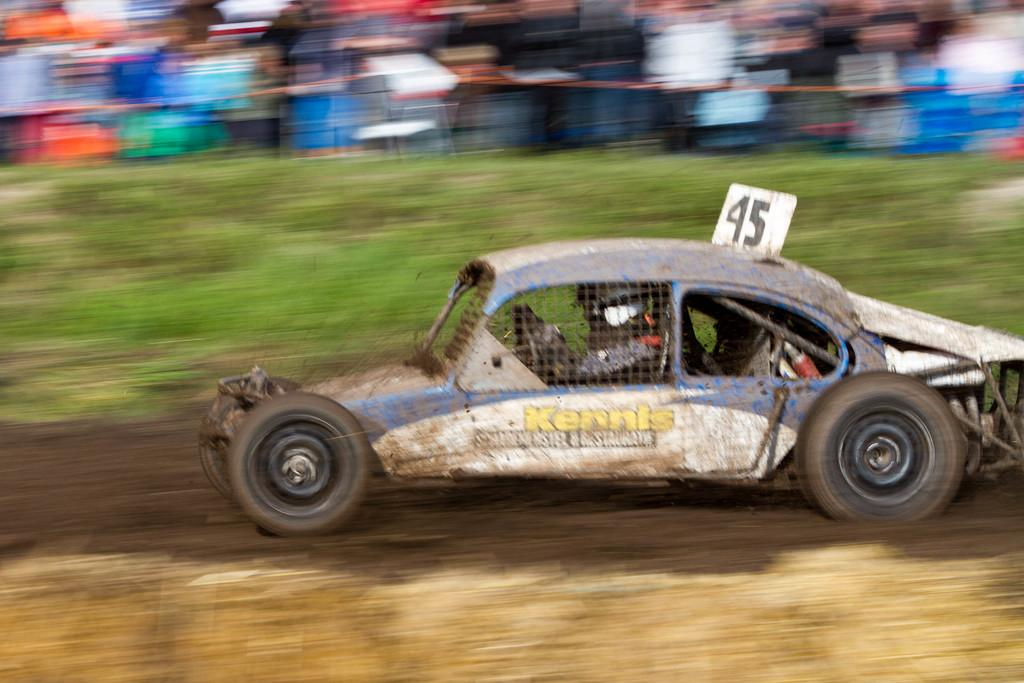What is the main subject in the foreground of the image? There is a car in the foreground of the image. What is the car doing in the image? The car is moving on the ground. Can you describe the background of the image? The background of the image is blurred. How many moons can be seen in the image? There are no moons visible in the image; it features a car moving on the ground with a blurred background. 